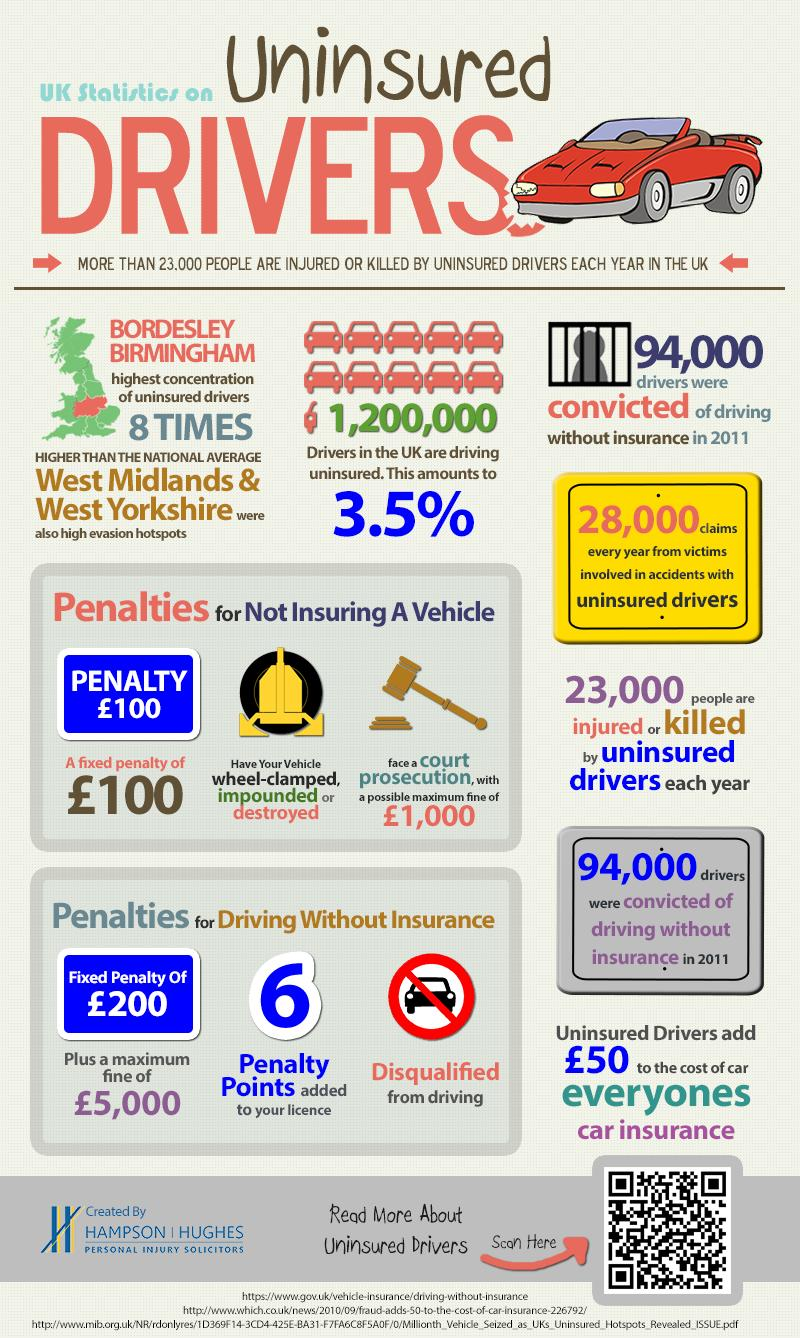Indicate a few pertinent items in this graphic. In 2011, it was found that only 3.5% of drivers in the UK were driving uninsured. If a driver in the UK is convicted of driving without a license in 2011, they may have received six penalty points added to their license. In the year 2011, the maximum fine for driving without a license in the United Kingdom was £5,000. In 2011, it is estimated that approximately 94,000 drivers in the United Kingdom were convicted of driving without having adequate insurance coverage. In 2011, the fixed penalty for not insuring a vehicle in the United Kingdom was £100. 